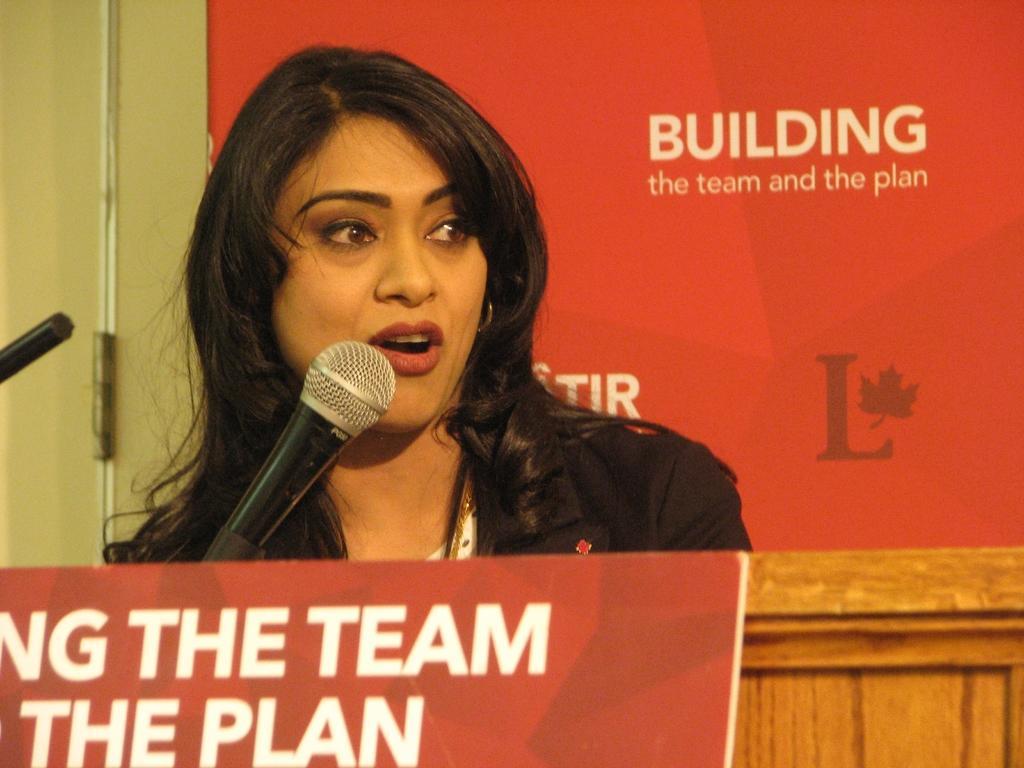Could you give a brief overview of what you see in this image? This picture shows a woman standing and speaking with the help of a microphone and we see couple of boards with text. 